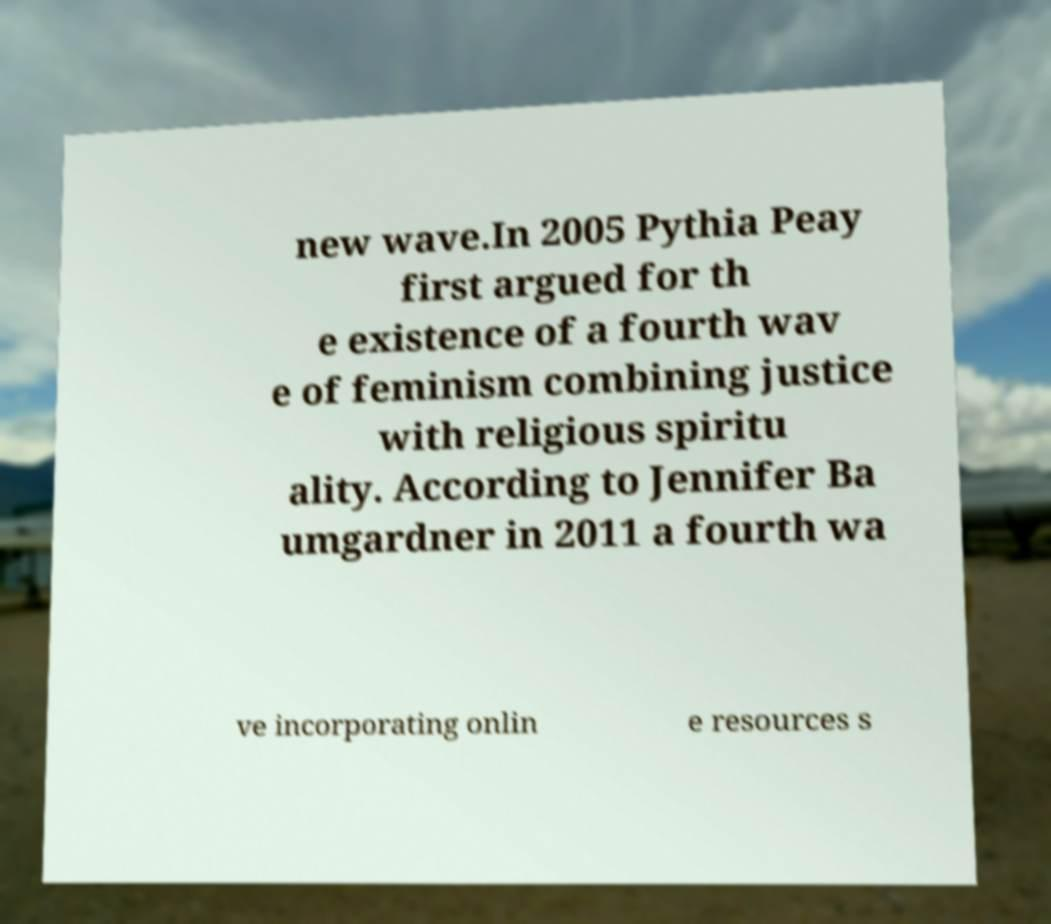Please read and relay the text visible in this image. What does it say? new wave.In 2005 Pythia Peay first argued for th e existence of a fourth wav e of feminism combining justice with religious spiritu ality. According to Jennifer Ba umgardner in 2011 a fourth wa ve incorporating onlin e resources s 